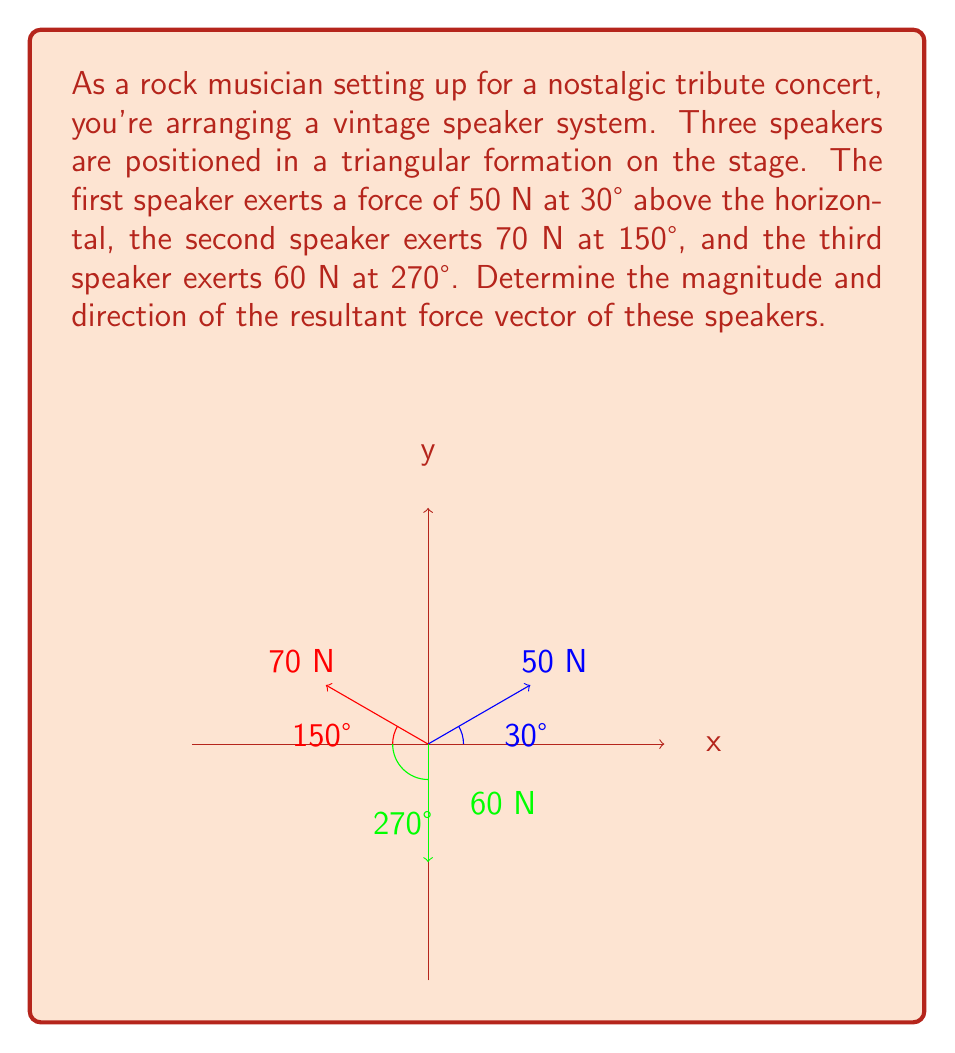Provide a solution to this math problem. Let's approach this step-by-step:

1) First, we need to break down each force vector into its x and y components:

   For the 50 N force at 30°:
   $F_{1x} = 50 \cos 30° = 50 \cdot \frac{\sqrt{3}}{2} = 25\sqrt{3}$ N
   $F_{1y} = 50 \sin 30° = 50 \cdot \frac{1}{2} = 25$ N

   For the 70 N force at 150°:
   $F_{2x} = 70 \cos 150° = 70 \cdot (-\frac{\sqrt{3}}{2}) = -35\sqrt{3}$ N
   $F_{2y} = 70 \sin 150° = 70 \cdot \frac{1}{2} = 35$ N

   For the 60 N force at 270°:
   $F_{3x} = 60 \cos 270° = 0$ N
   $F_{3y} = 60 \sin 270° = -60$ N

2) Now, we sum up all the x components and y components separately:

   $F_x = F_{1x} + F_{2x} + F_{3x} = 25\sqrt{3} - 35\sqrt{3} + 0 = -10\sqrt{3}$ N
   $F_y = F_{1y} + F_{2y} + F_{3y} = 25 + 35 - 60 = 0$ N

3) The resultant force vector is $\vec{R} = (F_x, F_y) = (-10\sqrt{3}, 0)$ N

4) To find the magnitude of the resultant force:

   $|\vec{R}| = \sqrt{F_x^2 + F_y^2} = \sqrt{(-10\sqrt{3})^2 + 0^2} = \sqrt{300} = 10\sqrt{3}$ N

5) To find the direction, we use the arctangent function:

   $\theta = \tan^{-1}(\frac{F_y}{F_x}) = \tan^{-1}(\frac{0}{-10\sqrt{3}}) = 180°$

   Note: Since $F_x$ is negative and $F_y$ is zero, the angle is 180°.
Answer: $10\sqrt{3}$ N at 180° 